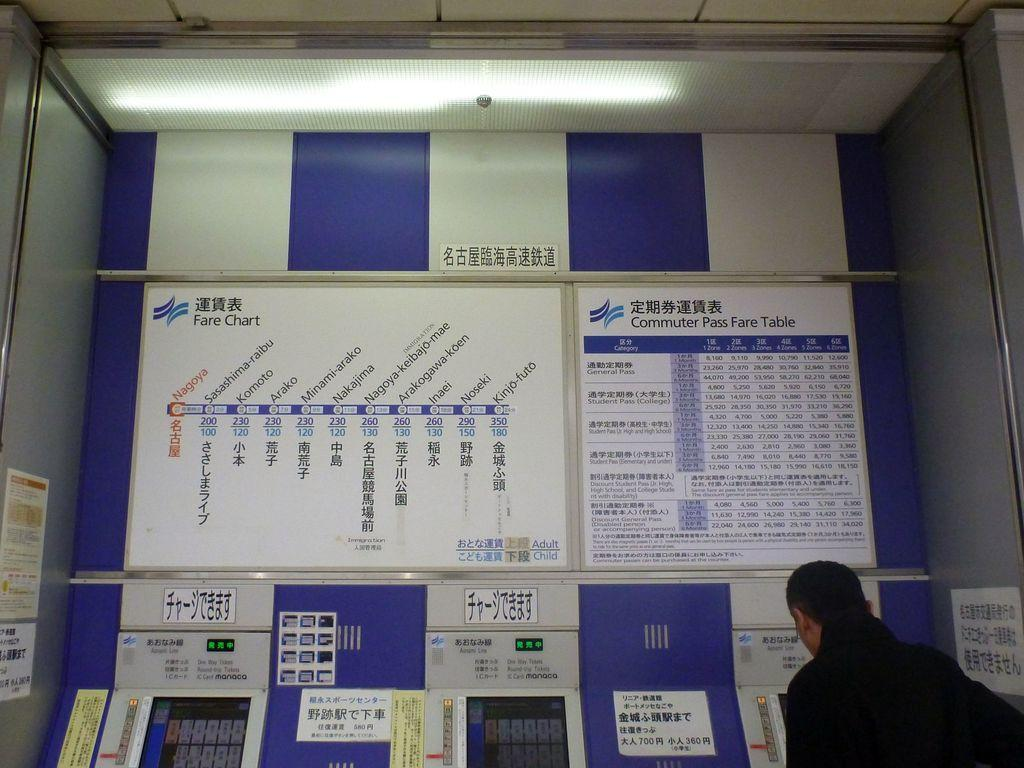<image>
Share a concise interpretation of the image provided. A man is buying a ticket at the Commuter Pass ticket machine. 